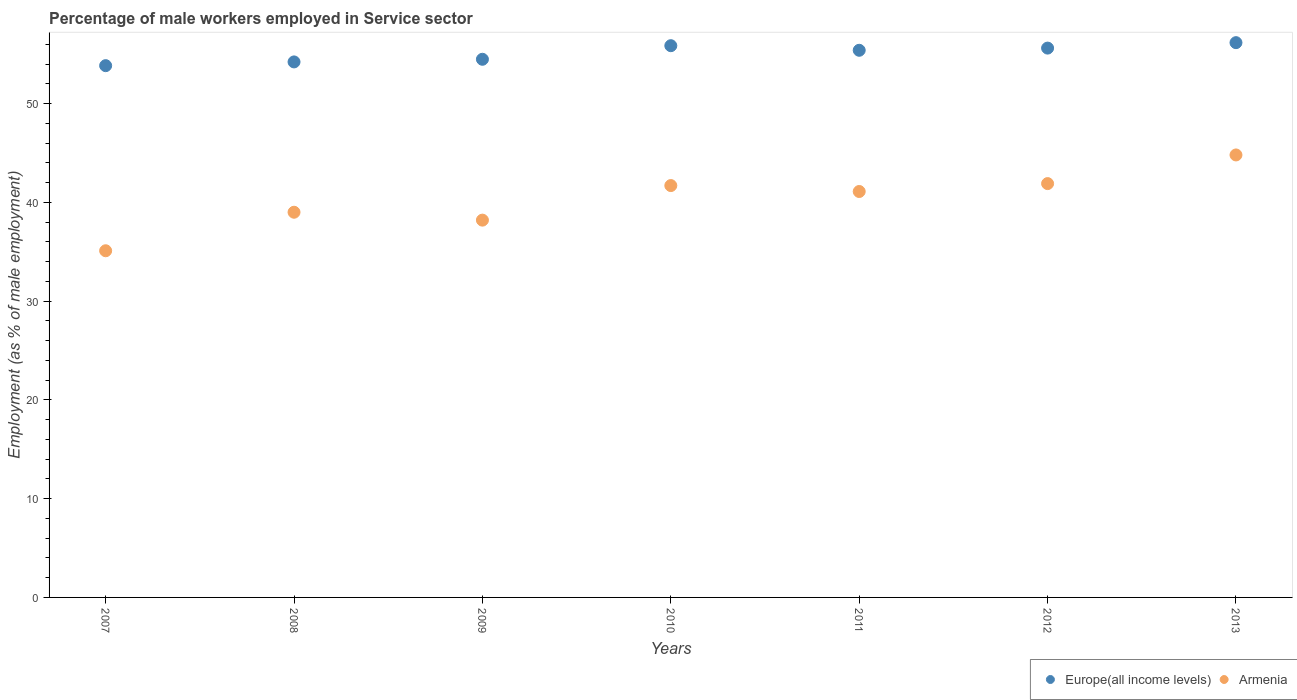Is the number of dotlines equal to the number of legend labels?
Your response must be concise. Yes. What is the percentage of male workers employed in Service sector in Armenia in 2007?
Give a very brief answer. 35.1. Across all years, what is the maximum percentage of male workers employed in Service sector in Armenia?
Make the answer very short. 44.8. Across all years, what is the minimum percentage of male workers employed in Service sector in Europe(all income levels)?
Your answer should be very brief. 53.84. In which year was the percentage of male workers employed in Service sector in Armenia maximum?
Offer a terse response. 2013. In which year was the percentage of male workers employed in Service sector in Europe(all income levels) minimum?
Keep it short and to the point. 2007. What is the total percentage of male workers employed in Service sector in Europe(all income levels) in the graph?
Provide a succinct answer. 385.6. What is the difference between the percentage of male workers employed in Service sector in Europe(all income levels) in 2009 and that in 2010?
Keep it short and to the point. -1.38. What is the difference between the percentage of male workers employed in Service sector in Armenia in 2007 and the percentage of male workers employed in Service sector in Europe(all income levels) in 2009?
Your answer should be very brief. -19.39. What is the average percentage of male workers employed in Service sector in Europe(all income levels) per year?
Your response must be concise. 55.09. In the year 2009, what is the difference between the percentage of male workers employed in Service sector in Armenia and percentage of male workers employed in Service sector in Europe(all income levels)?
Provide a short and direct response. -16.29. What is the ratio of the percentage of male workers employed in Service sector in Armenia in 2007 to that in 2010?
Keep it short and to the point. 0.84. Is the difference between the percentage of male workers employed in Service sector in Armenia in 2007 and 2008 greater than the difference between the percentage of male workers employed in Service sector in Europe(all income levels) in 2007 and 2008?
Offer a terse response. No. What is the difference between the highest and the second highest percentage of male workers employed in Service sector in Europe(all income levels)?
Provide a succinct answer. 0.31. What is the difference between the highest and the lowest percentage of male workers employed in Service sector in Armenia?
Your answer should be very brief. 9.7. Is the percentage of male workers employed in Service sector in Europe(all income levels) strictly less than the percentage of male workers employed in Service sector in Armenia over the years?
Your answer should be very brief. No. How many years are there in the graph?
Offer a terse response. 7. What is the difference between two consecutive major ticks on the Y-axis?
Your answer should be compact. 10. Are the values on the major ticks of Y-axis written in scientific E-notation?
Your answer should be compact. No. Does the graph contain any zero values?
Offer a very short reply. No. Does the graph contain grids?
Ensure brevity in your answer.  No. Where does the legend appear in the graph?
Offer a terse response. Bottom right. How many legend labels are there?
Offer a very short reply. 2. How are the legend labels stacked?
Make the answer very short. Horizontal. What is the title of the graph?
Keep it short and to the point. Percentage of male workers employed in Service sector. What is the label or title of the Y-axis?
Offer a very short reply. Employment (as % of male employment). What is the Employment (as % of male employment) of Europe(all income levels) in 2007?
Provide a short and direct response. 53.84. What is the Employment (as % of male employment) of Armenia in 2007?
Offer a very short reply. 35.1. What is the Employment (as % of male employment) of Europe(all income levels) in 2008?
Your answer should be compact. 54.22. What is the Employment (as % of male employment) of Europe(all income levels) in 2009?
Your answer should be compact. 54.49. What is the Employment (as % of male employment) of Armenia in 2009?
Provide a short and direct response. 38.2. What is the Employment (as % of male employment) in Europe(all income levels) in 2010?
Your answer should be very brief. 55.86. What is the Employment (as % of male employment) of Armenia in 2010?
Offer a very short reply. 41.7. What is the Employment (as % of male employment) of Europe(all income levels) in 2011?
Your answer should be compact. 55.4. What is the Employment (as % of male employment) in Armenia in 2011?
Provide a short and direct response. 41.1. What is the Employment (as % of male employment) in Europe(all income levels) in 2012?
Keep it short and to the point. 55.62. What is the Employment (as % of male employment) in Armenia in 2012?
Your response must be concise. 41.9. What is the Employment (as % of male employment) in Europe(all income levels) in 2013?
Keep it short and to the point. 56.17. What is the Employment (as % of male employment) of Armenia in 2013?
Offer a terse response. 44.8. Across all years, what is the maximum Employment (as % of male employment) in Europe(all income levels)?
Ensure brevity in your answer.  56.17. Across all years, what is the maximum Employment (as % of male employment) in Armenia?
Provide a succinct answer. 44.8. Across all years, what is the minimum Employment (as % of male employment) of Europe(all income levels)?
Provide a short and direct response. 53.84. Across all years, what is the minimum Employment (as % of male employment) in Armenia?
Your response must be concise. 35.1. What is the total Employment (as % of male employment) in Europe(all income levels) in the graph?
Offer a very short reply. 385.6. What is the total Employment (as % of male employment) in Armenia in the graph?
Your answer should be very brief. 281.8. What is the difference between the Employment (as % of male employment) in Europe(all income levels) in 2007 and that in 2008?
Ensure brevity in your answer.  -0.38. What is the difference between the Employment (as % of male employment) in Europe(all income levels) in 2007 and that in 2009?
Provide a short and direct response. -0.65. What is the difference between the Employment (as % of male employment) of Europe(all income levels) in 2007 and that in 2010?
Offer a very short reply. -2.02. What is the difference between the Employment (as % of male employment) of Armenia in 2007 and that in 2010?
Ensure brevity in your answer.  -6.6. What is the difference between the Employment (as % of male employment) of Europe(all income levels) in 2007 and that in 2011?
Your response must be concise. -1.56. What is the difference between the Employment (as % of male employment) in Armenia in 2007 and that in 2011?
Your answer should be very brief. -6. What is the difference between the Employment (as % of male employment) in Europe(all income levels) in 2007 and that in 2012?
Ensure brevity in your answer.  -1.78. What is the difference between the Employment (as % of male employment) of Europe(all income levels) in 2007 and that in 2013?
Keep it short and to the point. -2.33. What is the difference between the Employment (as % of male employment) of Armenia in 2007 and that in 2013?
Your answer should be very brief. -9.7. What is the difference between the Employment (as % of male employment) of Europe(all income levels) in 2008 and that in 2009?
Ensure brevity in your answer.  -0.27. What is the difference between the Employment (as % of male employment) in Armenia in 2008 and that in 2009?
Keep it short and to the point. 0.8. What is the difference between the Employment (as % of male employment) of Europe(all income levels) in 2008 and that in 2010?
Your response must be concise. -1.64. What is the difference between the Employment (as % of male employment) in Armenia in 2008 and that in 2010?
Keep it short and to the point. -2.7. What is the difference between the Employment (as % of male employment) in Europe(all income levels) in 2008 and that in 2011?
Offer a terse response. -1.18. What is the difference between the Employment (as % of male employment) in Armenia in 2008 and that in 2011?
Offer a terse response. -2.1. What is the difference between the Employment (as % of male employment) in Europe(all income levels) in 2008 and that in 2012?
Make the answer very short. -1.4. What is the difference between the Employment (as % of male employment) in Europe(all income levels) in 2008 and that in 2013?
Keep it short and to the point. -1.95. What is the difference between the Employment (as % of male employment) in Europe(all income levels) in 2009 and that in 2010?
Offer a very short reply. -1.38. What is the difference between the Employment (as % of male employment) of Europe(all income levels) in 2009 and that in 2011?
Ensure brevity in your answer.  -0.91. What is the difference between the Employment (as % of male employment) in Europe(all income levels) in 2009 and that in 2012?
Provide a short and direct response. -1.13. What is the difference between the Employment (as % of male employment) in Europe(all income levels) in 2009 and that in 2013?
Your answer should be compact. -1.68. What is the difference between the Employment (as % of male employment) of Europe(all income levels) in 2010 and that in 2011?
Offer a terse response. 0.47. What is the difference between the Employment (as % of male employment) in Europe(all income levels) in 2010 and that in 2012?
Keep it short and to the point. 0.24. What is the difference between the Employment (as % of male employment) of Armenia in 2010 and that in 2012?
Make the answer very short. -0.2. What is the difference between the Employment (as % of male employment) in Europe(all income levels) in 2010 and that in 2013?
Your answer should be very brief. -0.31. What is the difference between the Employment (as % of male employment) of Armenia in 2010 and that in 2013?
Keep it short and to the point. -3.1. What is the difference between the Employment (as % of male employment) of Europe(all income levels) in 2011 and that in 2012?
Keep it short and to the point. -0.22. What is the difference between the Employment (as % of male employment) of Armenia in 2011 and that in 2012?
Provide a short and direct response. -0.8. What is the difference between the Employment (as % of male employment) in Europe(all income levels) in 2011 and that in 2013?
Your answer should be compact. -0.77. What is the difference between the Employment (as % of male employment) of Armenia in 2011 and that in 2013?
Your response must be concise. -3.7. What is the difference between the Employment (as % of male employment) of Europe(all income levels) in 2012 and that in 2013?
Offer a very short reply. -0.55. What is the difference between the Employment (as % of male employment) of Armenia in 2012 and that in 2013?
Your answer should be compact. -2.9. What is the difference between the Employment (as % of male employment) in Europe(all income levels) in 2007 and the Employment (as % of male employment) in Armenia in 2008?
Give a very brief answer. 14.84. What is the difference between the Employment (as % of male employment) of Europe(all income levels) in 2007 and the Employment (as % of male employment) of Armenia in 2009?
Provide a short and direct response. 15.64. What is the difference between the Employment (as % of male employment) of Europe(all income levels) in 2007 and the Employment (as % of male employment) of Armenia in 2010?
Offer a very short reply. 12.14. What is the difference between the Employment (as % of male employment) of Europe(all income levels) in 2007 and the Employment (as % of male employment) of Armenia in 2011?
Make the answer very short. 12.74. What is the difference between the Employment (as % of male employment) of Europe(all income levels) in 2007 and the Employment (as % of male employment) of Armenia in 2012?
Your response must be concise. 11.94. What is the difference between the Employment (as % of male employment) of Europe(all income levels) in 2007 and the Employment (as % of male employment) of Armenia in 2013?
Offer a very short reply. 9.04. What is the difference between the Employment (as % of male employment) in Europe(all income levels) in 2008 and the Employment (as % of male employment) in Armenia in 2009?
Your answer should be compact. 16.02. What is the difference between the Employment (as % of male employment) in Europe(all income levels) in 2008 and the Employment (as % of male employment) in Armenia in 2010?
Offer a very short reply. 12.52. What is the difference between the Employment (as % of male employment) of Europe(all income levels) in 2008 and the Employment (as % of male employment) of Armenia in 2011?
Give a very brief answer. 13.12. What is the difference between the Employment (as % of male employment) in Europe(all income levels) in 2008 and the Employment (as % of male employment) in Armenia in 2012?
Offer a terse response. 12.32. What is the difference between the Employment (as % of male employment) in Europe(all income levels) in 2008 and the Employment (as % of male employment) in Armenia in 2013?
Offer a very short reply. 9.42. What is the difference between the Employment (as % of male employment) of Europe(all income levels) in 2009 and the Employment (as % of male employment) of Armenia in 2010?
Make the answer very short. 12.79. What is the difference between the Employment (as % of male employment) of Europe(all income levels) in 2009 and the Employment (as % of male employment) of Armenia in 2011?
Your answer should be very brief. 13.39. What is the difference between the Employment (as % of male employment) of Europe(all income levels) in 2009 and the Employment (as % of male employment) of Armenia in 2012?
Keep it short and to the point. 12.59. What is the difference between the Employment (as % of male employment) of Europe(all income levels) in 2009 and the Employment (as % of male employment) of Armenia in 2013?
Your answer should be very brief. 9.69. What is the difference between the Employment (as % of male employment) of Europe(all income levels) in 2010 and the Employment (as % of male employment) of Armenia in 2011?
Offer a terse response. 14.76. What is the difference between the Employment (as % of male employment) of Europe(all income levels) in 2010 and the Employment (as % of male employment) of Armenia in 2012?
Ensure brevity in your answer.  13.96. What is the difference between the Employment (as % of male employment) in Europe(all income levels) in 2010 and the Employment (as % of male employment) in Armenia in 2013?
Offer a very short reply. 11.06. What is the difference between the Employment (as % of male employment) of Europe(all income levels) in 2011 and the Employment (as % of male employment) of Armenia in 2012?
Offer a terse response. 13.5. What is the difference between the Employment (as % of male employment) in Europe(all income levels) in 2011 and the Employment (as % of male employment) in Armenia in 2013?
Offer a terse response. 10.6. What is the difference between the Employment (as % of male employment) of Europe(all income levels) in 2012 and the Employment (as % of male employment) of Armenia in 2013?
Provide a short and direct response. 10.82. What is the average Employment (as % of male employment) in Europe(all income levels) per year?
Give a very brief answer. 55.09. What is the average Employment (as % of male employment) of Armenia per year?
Make the answer very short. 40.26. In the year 2007, what is the difference between the Employment (as % of male employment) of Europe(all income levels) and Employment (as % of male employment) of Armenia?
Make the answer very short. 18.74. In the year 2008, what is the difference between the Employment (as % of male employment) in Europe(all income levels) and Employment (as % of male employment) in Armenia?
Your response must be concise. 15.22. In the year 2009, what is the difference between the Employment (as % of male employment) of Europe(all income levels) and Employment (as % of male employment) of Armenia?
Ensure brevity in your answer.  16.29. In the year 2010, what is the difference between the Employment (as % of male employment) of Europe(all income levels) and Employment (as % of male employment) of Armenia?
Offer a very short reply. 14.16. In the year 2011, what is the difference between the Employment (as % of male employment) of Europe(all income levels) and Employment (as % of male employment) of Armenia?
Your response must be concise. 14.3. In the year 2012, what is the difference between the Employment (as % of male employment) of Europe(all income levels) and Employment (as % of male employment) of Armenia?
Provide a succinct answer. 13.72. In the year 2013, what is the difference between the Employment (as % of male employment) of Europe(all income levels) and Employment (as % of male employment) of Armenia?
Your answer should be very brief. 11.37. What is the ratio of the Employment (as % of male employment) in Armenia in 2007 to that in 2008?
Provide a short and direct response. 0.9. What is the ratio of the Employment (as % of male employment) in Europe(all income levels) in 2007 to that in 2009?
Provide a short and direct response. 0.99. What is the ratio of the Employment (as % of male employment) of Armenia in 2007 to that in 2009?
Provide a succinct answer. 0.92. What is the ratio of the Employment (as % of male employment) in Europe(all income levels) in 2007 to that in 2010?
Offer a terse response. 0.96. What is the ratio of the Employment (as % of male employment) of Armenia in 2007 to that in 2010?
Your response must be concise. 0.84. What is the ratio of the Employment (as % of male employment) of Europe(all income levels) in 2007 to that in 2011?
Your response must be concise. 0.97. What is the ratio of the Employment (as % of male employment) in Armenia in 2007 to that in 2011?
Your response must be concise. 0.85. What is the ratio of the Employment (as % of male employment) in Armenia in 2007 to that in 2012?
Your answer should be compact. 0.84. What is the ratio of the Employment (as % of male employment) in Europe(all income levels) in 2007 to that in 2013?
Your answer should be compact. 0.96. What is the ratio of the Employment (as % of male employment) in Armenia in 2007 to that in 2013?
Keep it short and to the point. 0.78. What is the ratio of the Employment (as % of male employment) in Europe(all income levels) in 2008 to that in 2009?
Provide a succinct answer. 1. What is the ratio of the Employment (as % of male employment) in Armenia in 2008 to that in 2009?
Keep it short and to the point. 1.02. What is the ratio of the Employment (as % of male employment) of Europe(all income levels) in 2008 to that in 2010?
Provide a succinct answer. 0.97. What is the ratio of the Employment (as % of male employment) in Armenia in 2008 to that in 2010?
Your response must be concise. 0.94. What is the ratio of the Employment (as % of male employment) in Europe(all income levels) in 2008 to that in 2011?
Keep it short and to the point. 0.98. What is the ratio of the Employment (as % of male employment) in Armenia in 2008 to that in 2011?
Provide a succinct answer. 0.95. What is the ratio of the Employment (as % of male employment) of Europe(all income levels) in 2008 to that in 2012?
Your answer should be compact. 0.97. What is the ratio of the Employment (as % of male employment) in Armenia in 2008 to that in 2012?
Your answer should be very brief. 0.93. What is the ratio of the Employment (as % of male employment) of Europe(all income levels) in 2008 to that in 2013?
Provide a short and direct response. 0.97. What is the ratio of the Employment (as % of male employment) in Armenia in 2008 to that in 2013?
Keep it short and to the point. 0.87. What is the ratio of the Employment (as % of male employment) in Europe(all income levels) in 2009 to that in 2010?
Keep it short and to the point. 0.98. What is the ratio of the Employment (as % of male employment) in Armenia in 2009 to that in 2010?
Make the answer very short. 0.92. What is the ratio of the Employment (as % of male employment) in Europe(all income levels) in 2009 to that in 2011?
Give a very brief answer. 0.98. What is the ratio of the Employment (as % of male employment) in Armenia in 2009 to that in 2011?
Provide a succinct answer. 0.93. What is the ratio of the Employment (as % of male employment) in Europe(all income levels) in 2009 to that in 2012?
Keep it short and to the point. 0.98. What is the ratio of the Employment (as % of male employment) in Armenia in 2009 to that in 2012?
Offer a very short reply. 0.91. What is the ratio of the Employment (as % of male employment) of Europe(all income levels) in 2009 to that in 2013?
Keep it short and to the point. 0.97. What is the ratio of the Employment (as % of male employment) of Armenia in 2009 to that in 2013?
Your response must be concise. 0.85. What is the ratio of the Employment (as % of male employment) of Europe(all income levels) in 2010 to that in 2011?
Offer a very short reply. 1.01. What is the ratio of the Employment (as % of male employment) in Armenia in 2010 to that in 2011?
Your response must be concise. 1.01. What is the ratio of the Employment (as % of male employment) in Europe(all income levels) in 2010 to that in 2012?
Keep it short and to the point. 1. What is the ratio of the Employment (as % of male employment) of Armenia in 2010 to that in 2012?
Keep it short and to the point. 1. What is the ratio of the Employment (as % of male employment) in Armenia in 2010 to that in 2013?
Offer a very short reply. 0.93. What is the ratio of the Employment (as % of male employment) of Europe(all income levels) in 2011 to that in 2012?
Provide a succinct answer. 1. What is the ratio of the Employment (as % of male employment) of Armenia in 2011 to that in 2012?
Your response must be concise. 0.98. What is the ratio of the Employment (as % of male employment) in Europe(all income levels) in 2011 to that in 2013?
Your answer should be compact. 0.99. What is the ratio of the Employment (as % of male employment) in Armenia in 2011 to that in 2013?
Your answer should be very brief. 0.92. What is the ratio of the Employment (as % of male employment) in Europe(all income levels) in 2012 to that in 2013?
Your answer should be compact. 0.99. What is the ratio of the Employment (as % of male employment) of Armenia in 2012 to that in 2013?
Provide a succinct answer. 0.94. What is the difference between the highest and the second highest Employment (as % of male employment) of Europe(all income levels)?
Provide a short and direct response. 0.31. What is the difference between the highest and the second highest Employment (as % of male employment) in Armenia?
Give a very brief answer. 2.9. What is the difference between the highest and the lowest Employment (as % of male employment) of Europe(all income levels)?
Keep it short and to the point. 2.33. What is the difference between the highest and the lowest Employment (as % of male employment) in Armenia?
Make the answer very short. 9.7. 